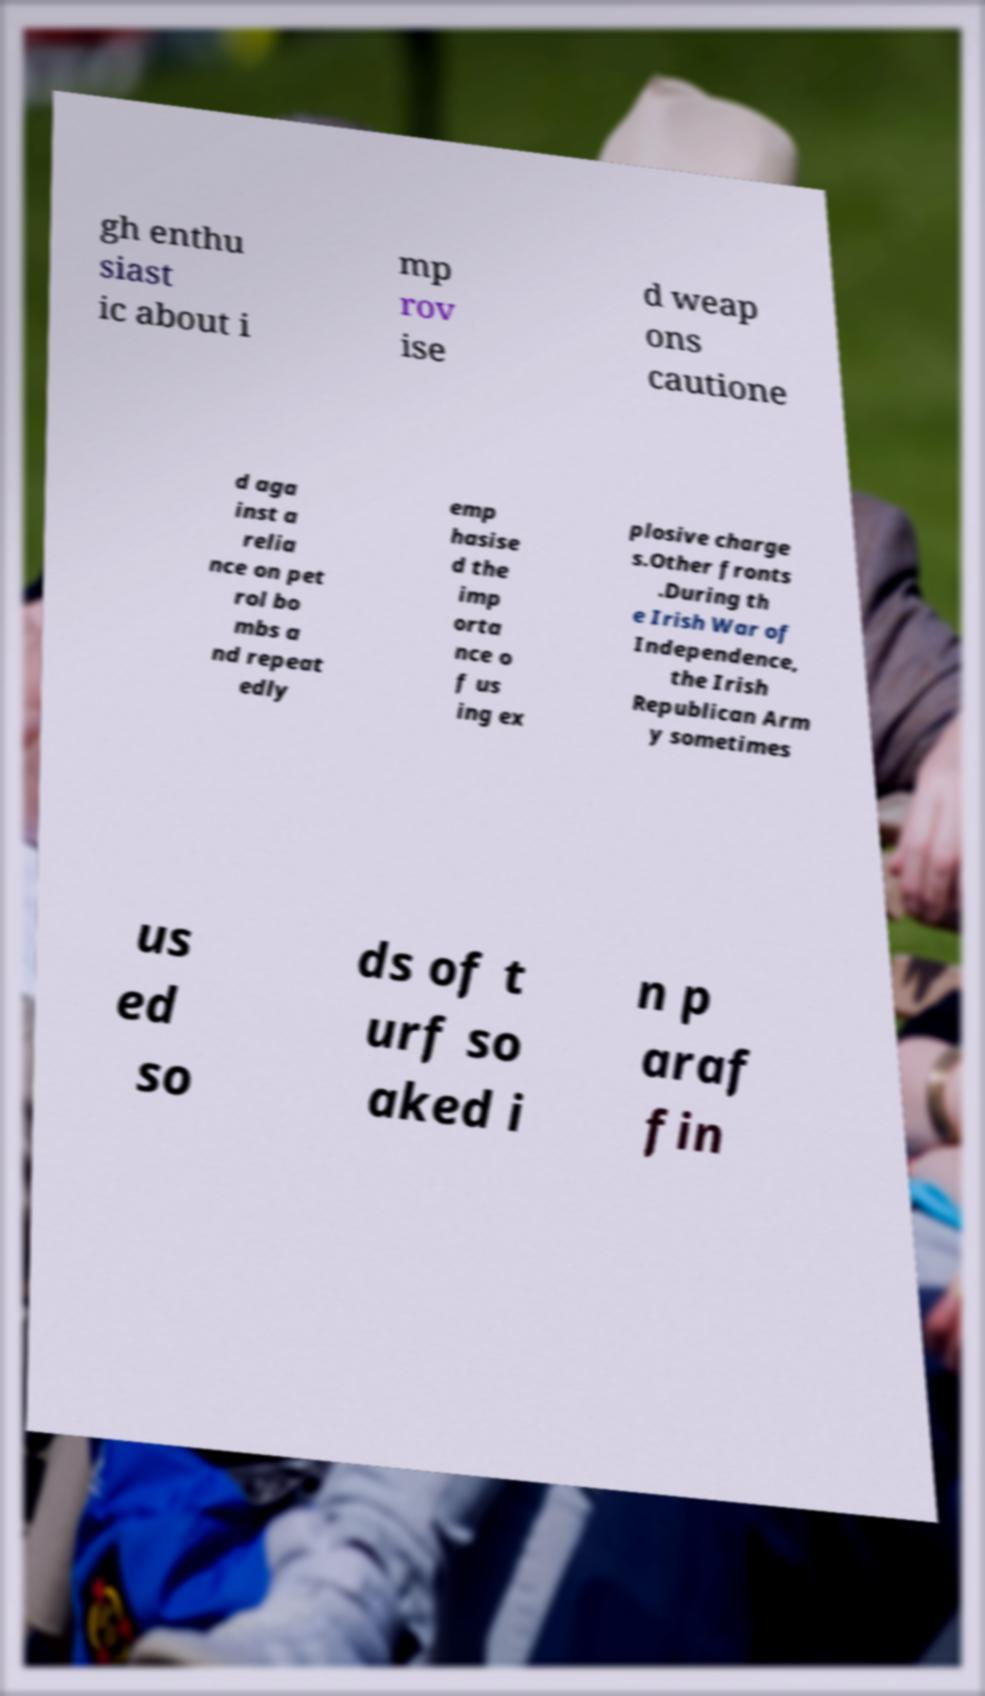What messages or text are displayed in this image? I need them in a readable, typed format. gh enthu siast ic about i mp rov ise d weap ons cautione d aga inst a relia nce on pet rol bo mbs a nd repeat edly emp hasise d the imp orta nce o f us ing ex plosive charge s.Other fronts .During th e Irish War of Independence, the Irish Republican Arm y sometimes us ed so ds of t urf so aked i n p araf fin 